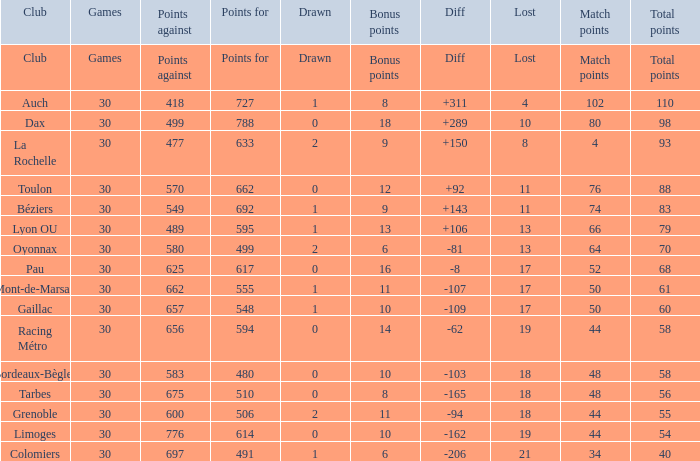What is the value of match points when the points for is 570? 76.0. 